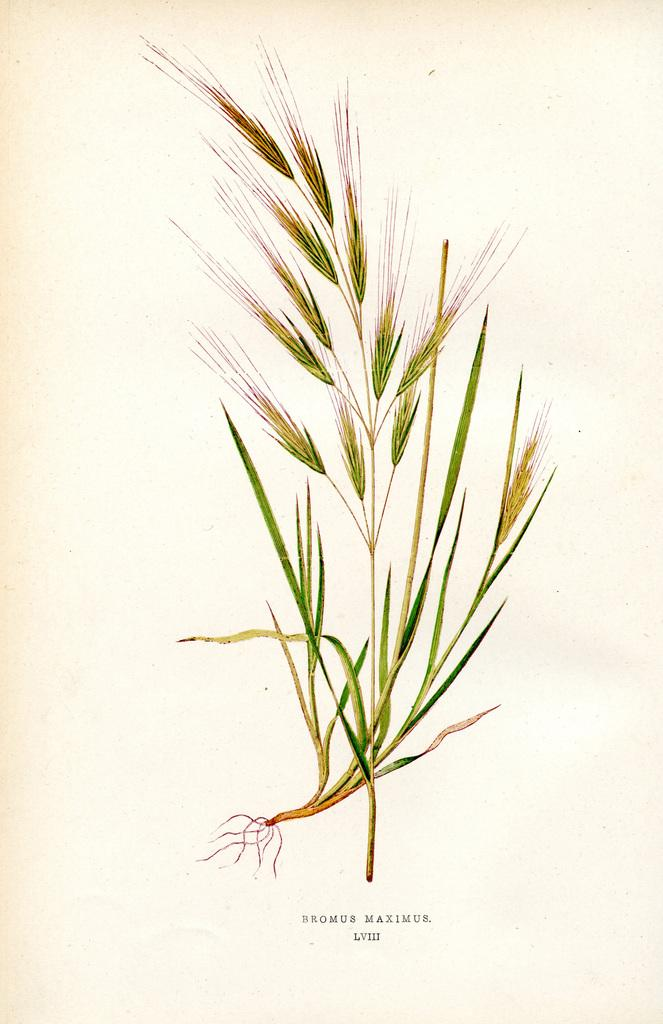What is the main subject of the image? The main subject of the image is a page. What type of content is depicted on the page? The page contains a diagram of grass. Is there any text accompanying the diagram? Yes, there is text on the page. What type of food is being served at the church depicted in the image? There is no church or food depicted in the image; it features a page with a diagram of grass and accompanying text. 